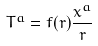<formula> <loc_0><loc_0><loc_500><loc_500>T ^ { a } = f ( r ) \frac { x ^ { a } } { r }</formula> 